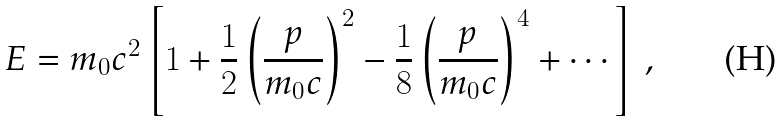<formula> <loc_0><loc_0><loc_500><loc_500>E = m _ { 0 } c ^ { 2 } \left [ 1 + { \frac { 1 } { 2 } } \left ( { \frac { p } { m _ { 0 } c } } \right ) ^ { 2 } - { \frac { 1 } { 8 } } \left ( { \frac { p } { m _ { 0 } c } } \right ) ^ { 4 } + \cdots \right ] \, ,</formula> 